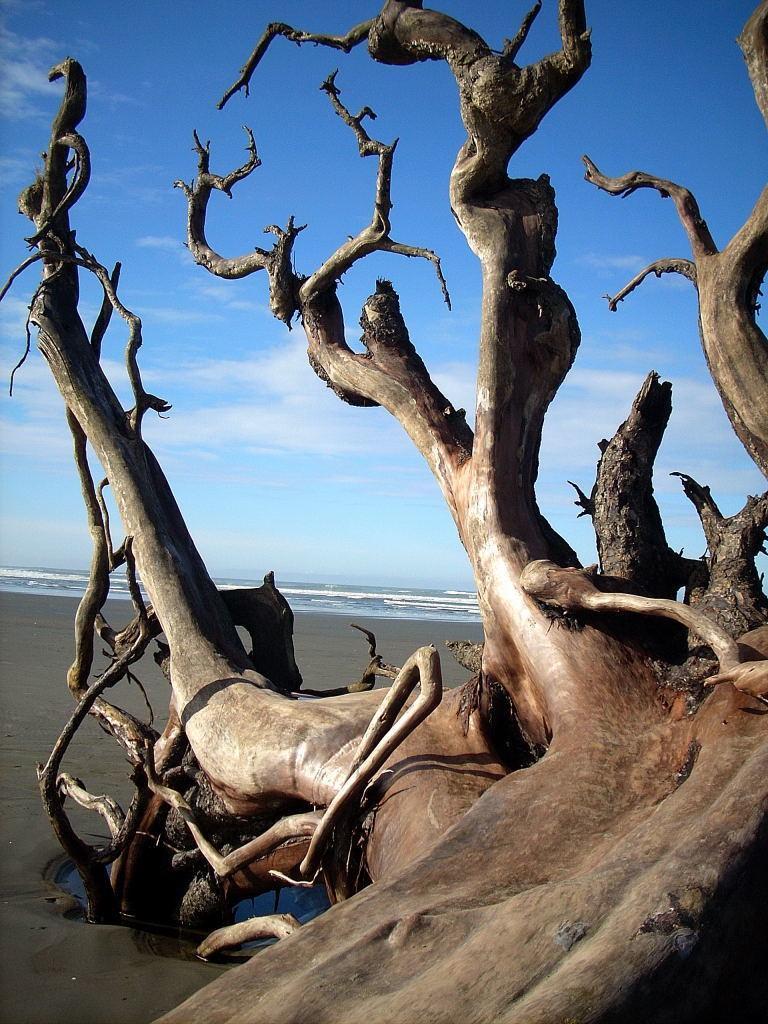In one or two sentences, can you explain what this image depicts? In this image can see the bark of a tree with some branches on the seashore. On the backside we can see a water body and the sky which looks cloudy. 